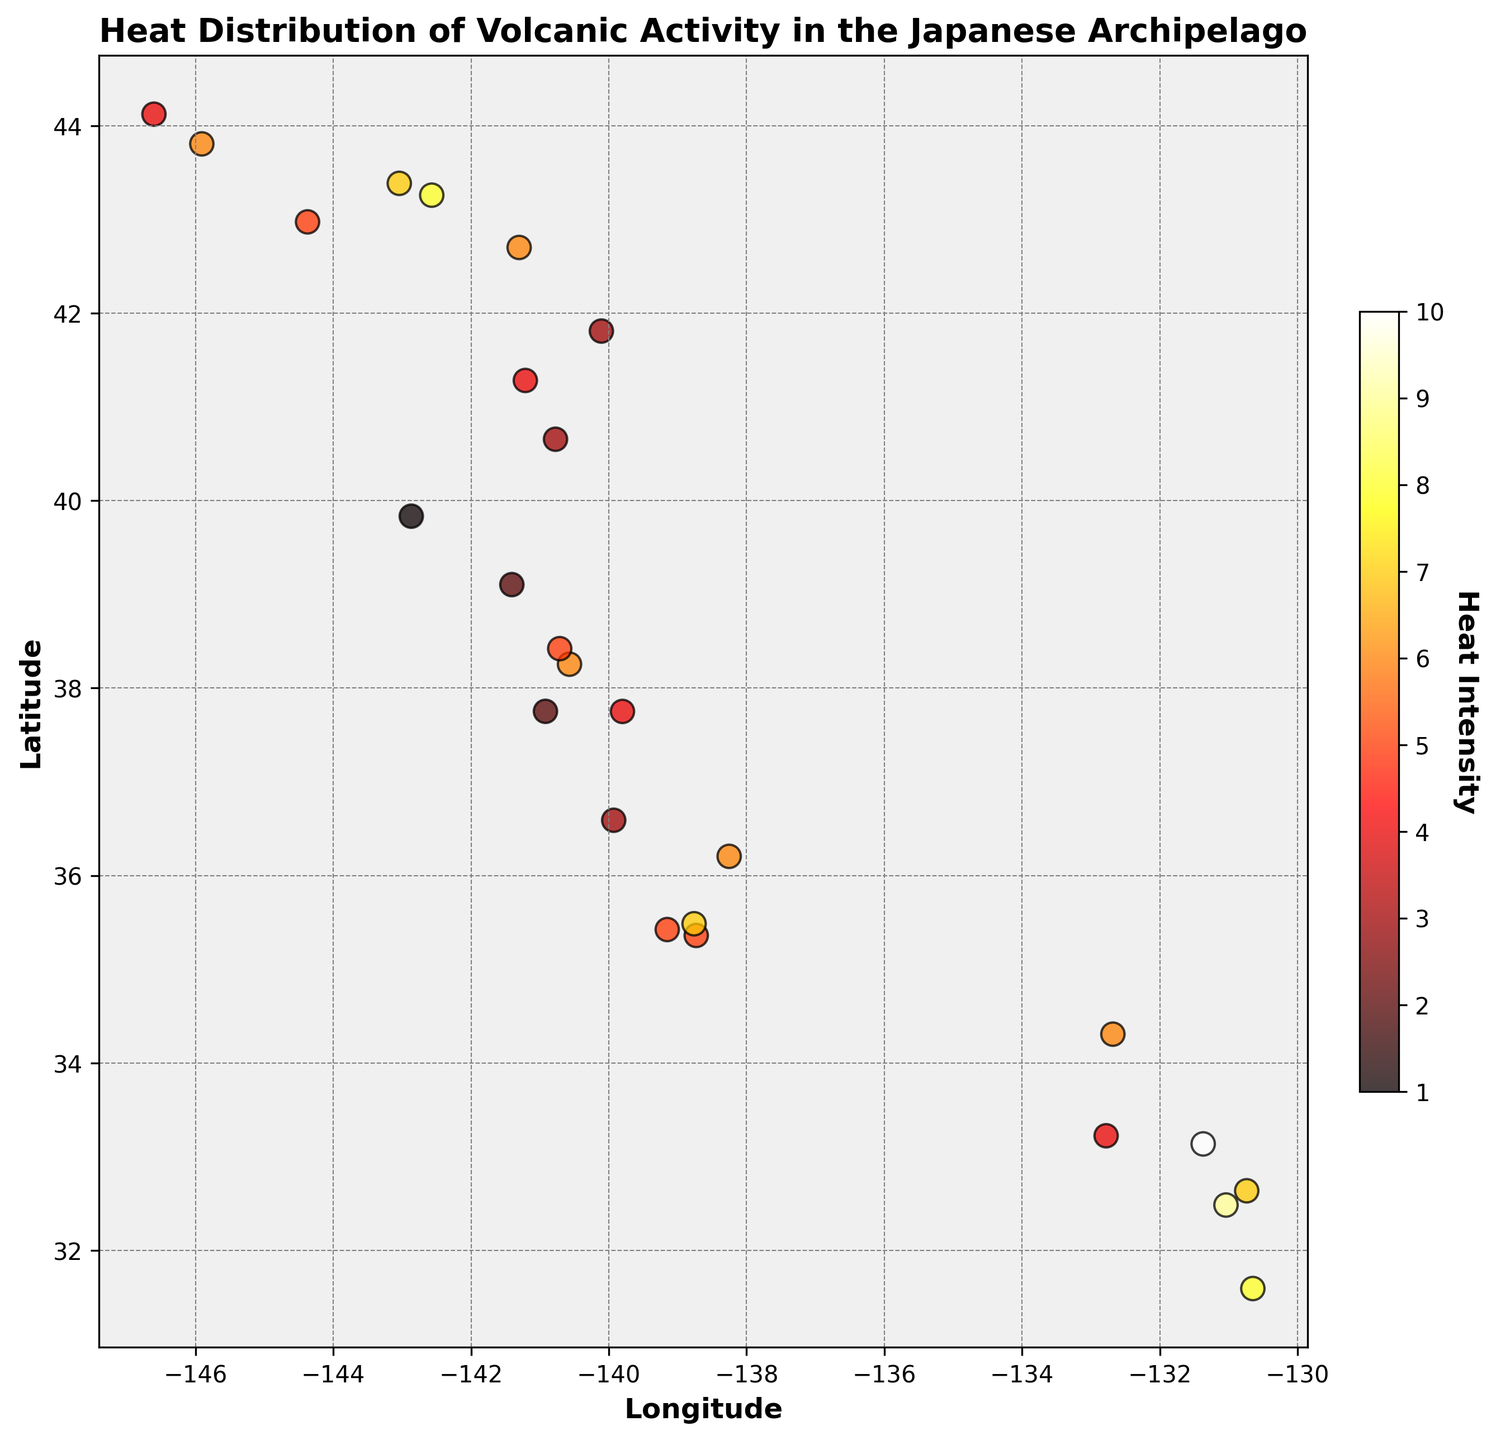Which region has the highest heat intensity? By observing the color and the location on the heatmap, the region with the highest heat intensity will be the darkest or deepest red spot. According to the colorbar, the deepest red corresponds to an intensity of 10. The coordinates for this location can be pinpointed in the figure.
Answer: 33.136,-131.371 Which regions have the lowest heat intensities and what is their intensity value? The lowest heat intensities will appear as the lightest colors on the heatmap. According to the colorbar, the lightest shade corresponds to an intensity of 1. We can identify this by locating the lightest spots on the heatmap.
Answer: 39.833,-142.868 How does the heat intensity at latitude 35.360 compare to that at latitude 35.485? By locating the two specified latitudes on the heatmap, we can compare the colors indicating their heat intensities. Latitude 35.360 corresponds to a heat intensity of 5, while latitude 35.485 corresponds to a heat intensity of 7. Therefore, 35.485 has a higher heat intensity than 35.360.
Answer: 7 > 5 Is there a correlation between latitude and heat intensity? To determine the correlation, observe if there's a gradient or pattern in the color changes from the south (lower latitudes) to the north (higher latitudes). If the colors change systematically, it suggests a correlation. If not, it indicates little to no correlation.
Answer: No clear pattern indicating a strong correlation What is the average heat intensity for regions within latitudes 41.0 to 44.0? First, identify the regions within the specified latitude range: \(41.281, 41.808, 42.700, 42.973, 43.258, 43.384\). Then, sum their heat intensities \(4+3+6+5+8+7=33\) and divide by the number of regions \(33/6 = 5.5\).
Answer: 5.5 Which region shows the greatest variation in heat intensity within 32.0 to 35.0 degrees latitude? Examine the heatmap within latitudes 32.0 to 35.0, noting different intensities are marked by different shades. The greatest variation will be identified where the color shifts the most within the specified range.
Answer: 32.484,-131.040 to 33.136,-131.371 What is the sum of heat intensities for all regions in Hokkaido (latitude > 42)? Identify heat intensities for all regions with latitude greater than 42: \(6, 5, 8, 7, 6, 4\). Sum these values: \(6 + 5 + 8 + 7 + 6 + 4 = 36\).
Answer: 36 Identify any regions with equal heat intensity values and provide their coordinates. Locate regions of the same color intensity on the heatmap and list their coordinates. Several regions such as 35.360,-138.731 and 35.423,-139.152 both have a heat intensity of 5.
Answer: Latitude: 35.360, Longitude: -138.731 and Latitude: 35.423, Longitude: -139.152 Do higher longitudes correspond to higher heat intensities? Observe the heatmap for an overall trend of increasing color intensity (heat) with increasing longitude. If there is no consistent trend, there is no correlation.
Answer: No clear correlation 